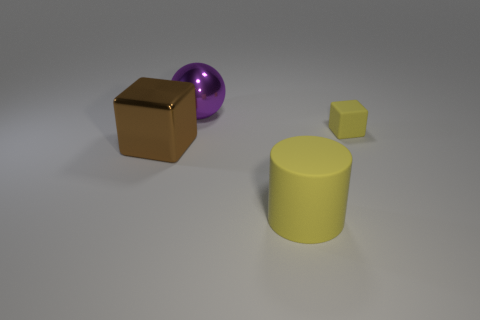Add 4 red rubber things. How many objects exist? 8 Subtract all cylinders. How many objects are left? 3 Add 2 brown things. How many brown things exist? 3 Subtract 0 cyan spheres. How many objects are left? 4 Subtract all large yellow things. Subtract all purple spheres. How many objects are left? 2 Add 4 yellow things. How many yellow things are left? 6 